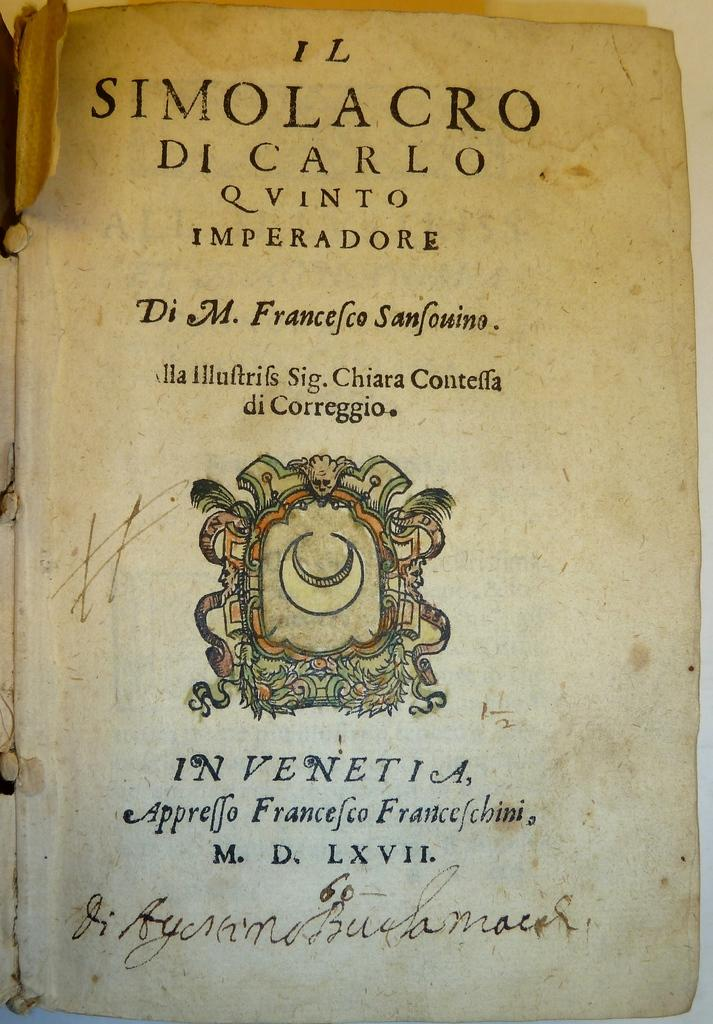<image>
Offer a succinct explanation of the picture presented. A tattered historical book written by Francesco Sansouino 